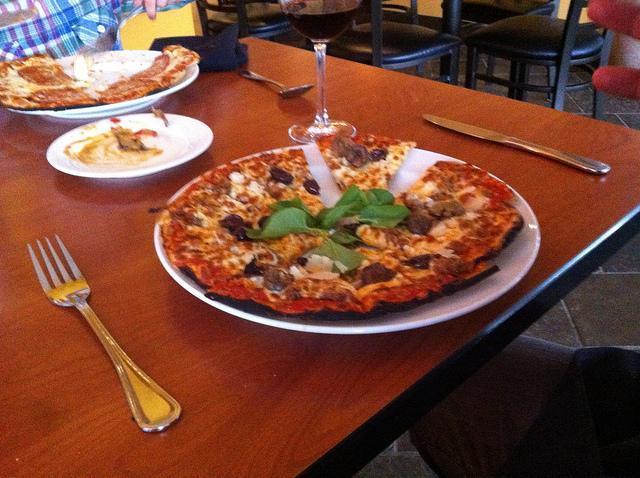How many people are dining?
Give a very brief answer. 2. How many slices does this pizza have?
Give a very brief answer. 8. How many people can you see?
Give a very brief answer. 2. How many chairs are in the photo?
Give a very brief answer. 3. How many pizzas are in the photo?
Give a very brief answer. 2. How many books are on the sign?
Give a very brief answer. 0. 